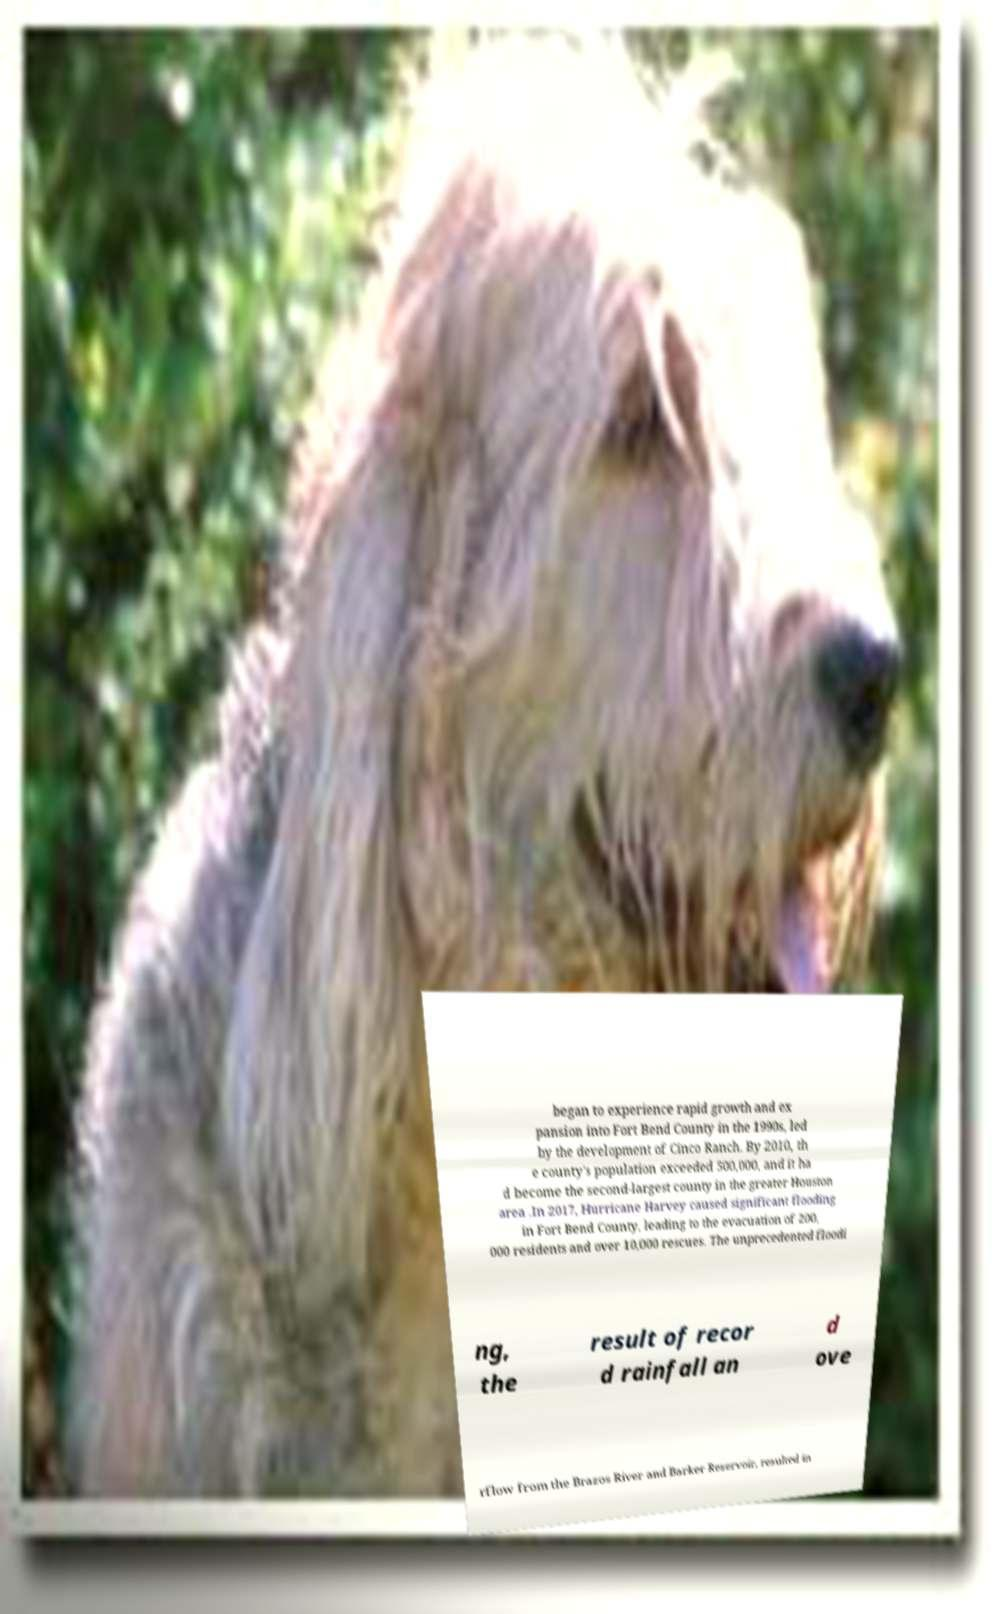For documentation purposes, I need the text within this image transcribed. Could you provide that? began to experience rapid growth and ex pansion into Fort Bend County in the 1990s, led by the development of Cinco Ranch. By 2010, th e county's population exceeded 500,000, and it ha d become the second-largest county in the greater Houston area .In 2017, Hurricane Harvey caused significant flooding in Fort Bend County, leading to the evacuation of 200, 000 residents and over 10,000 rescues. The unprecedented floodi ng, the result of recor d rainfall an d ove rflow from the Brazos River and Barker Reservoir, resulted in 